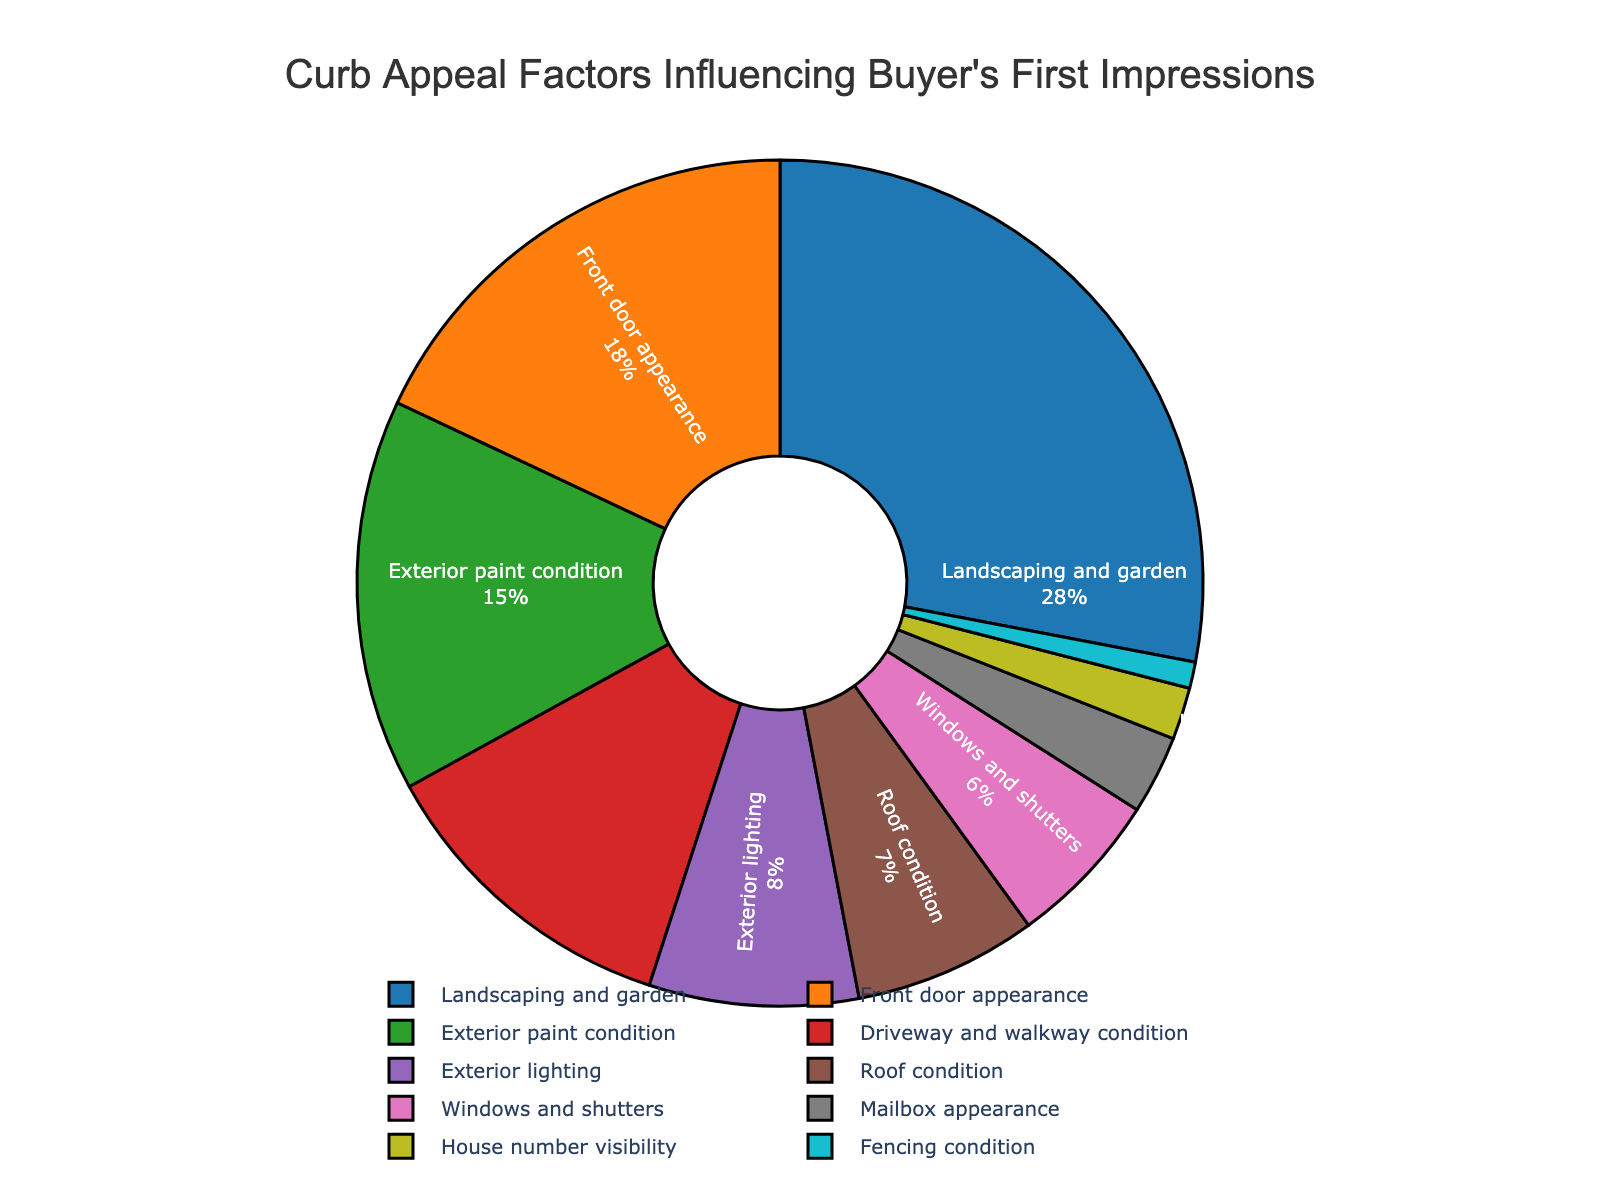Which aspect has the highest percentage influence on a buyer's first impressions? By examining the pie chart, we can see that "Landscaping and garden" holds the largest segment, thus it has the highest percentage influence.
Answer: Landscaping and garden Which two aspects together make up less than 10% of the total influence? "Mailbox appearance" and "House number visibility" each represent 3% and 2% respectively. Adding these gives 5%, which is less than 10%.
Answer: Mailbox appearance and House number visibility How much more influential is "Front door appearance" compared to "Roof condition"? "Front door appearance" is 18%, "Roof condition" is 7%. The difference is 18% - 7% = 11%.
Answer: 11% Which aspect has a lower percentage influence than "Exterior paint condition" but higher than "Exterior lighting"? "Driveway and walkway condition" has 12%, which is less than "Exterior paint condition" (15%) and more than "Exterior lighting" (8%).
Answer: Driveway and walkway condition What is the combined percentage influence of "Windows and shutters" and "Fencing condition"? "Windows and shutters" hold 6% and "Fencing condition" holds 1%. Combined, they make 6% + 1% = 7%.
Answer: 7% Which aspect is represented in blue? Based on the pie chart's color scheme, "Landscaping and garden" is represented in blue.
Answer: Landscaping and garden Is "Driveway and walkway condition" more influential than "Exterior lighting"? "Driveway and walkway condition" stands at 12%, whereas "Exterior lighting" is at 8%. Since 12% is greater than 8%, it is more influential.
Answer: Yes Which aspect influences buyer’s first impressions the least? The smallest segment on the pie chart represents "Fencing condition" with 1%.
Answer: Fencing condition How many aspects contribute equally to the buyer's first impression? By examining the pie chart, there's no indication of multiple aspects having the same percentage.
Answer: None 